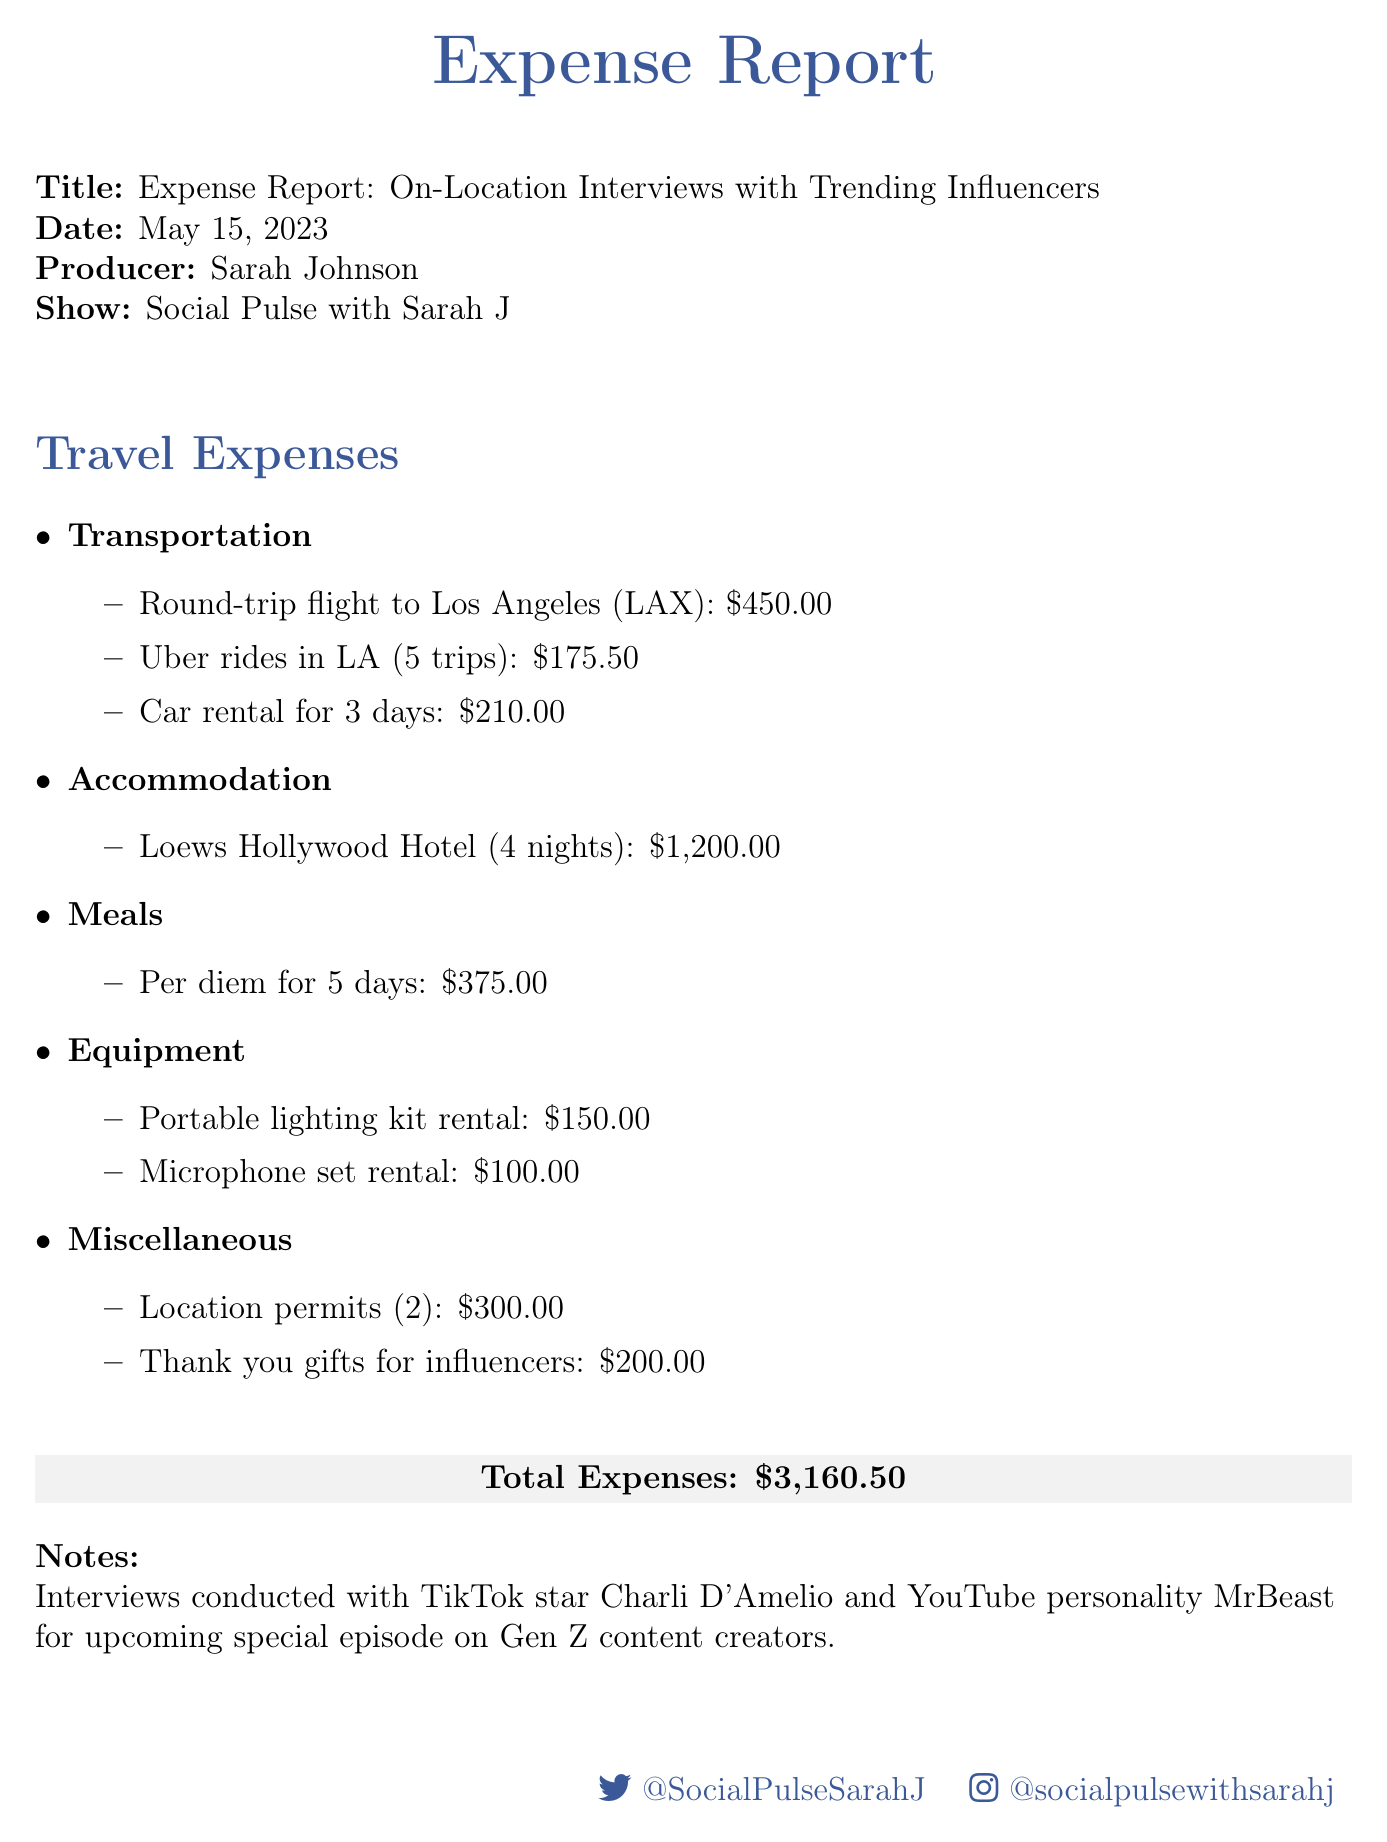what is the date of the expense report? The date of the expense report is clearly mentioned in the document.
Answer: May 15, 2023 who is the producer of the show? The name of the producer is provided in the document.
Answer: Sarah Johnson what is the total amount of expenses? The total expenses are summarized at the end of the document.
Answer: $3,160.50 how many nights was accommodation booked? The accommodation details specify the number of nights.
Answer: 4 nights what is the cost for thank you gifts for influencers? The miscellaneous expenses include the amount for thank you gifts.
Answer: $200.00 how many trips were made using Uber in Los Angeles? The transportation section lists the number of Uber rides.
Answer: 5 trips who were the influencers interviewed? The notes section mentions the names of the influencers featured in the interviews.
Answer: Charli D'Amelio and MrBeast what was the cost of the round-trip flight? The transportation expenses clearly state the flight cost.
Answer: $450.00 what equipment was rented? The equipment section details the items that were rented for the interviews.
Answer: Portable lighting kit and Microphone set 